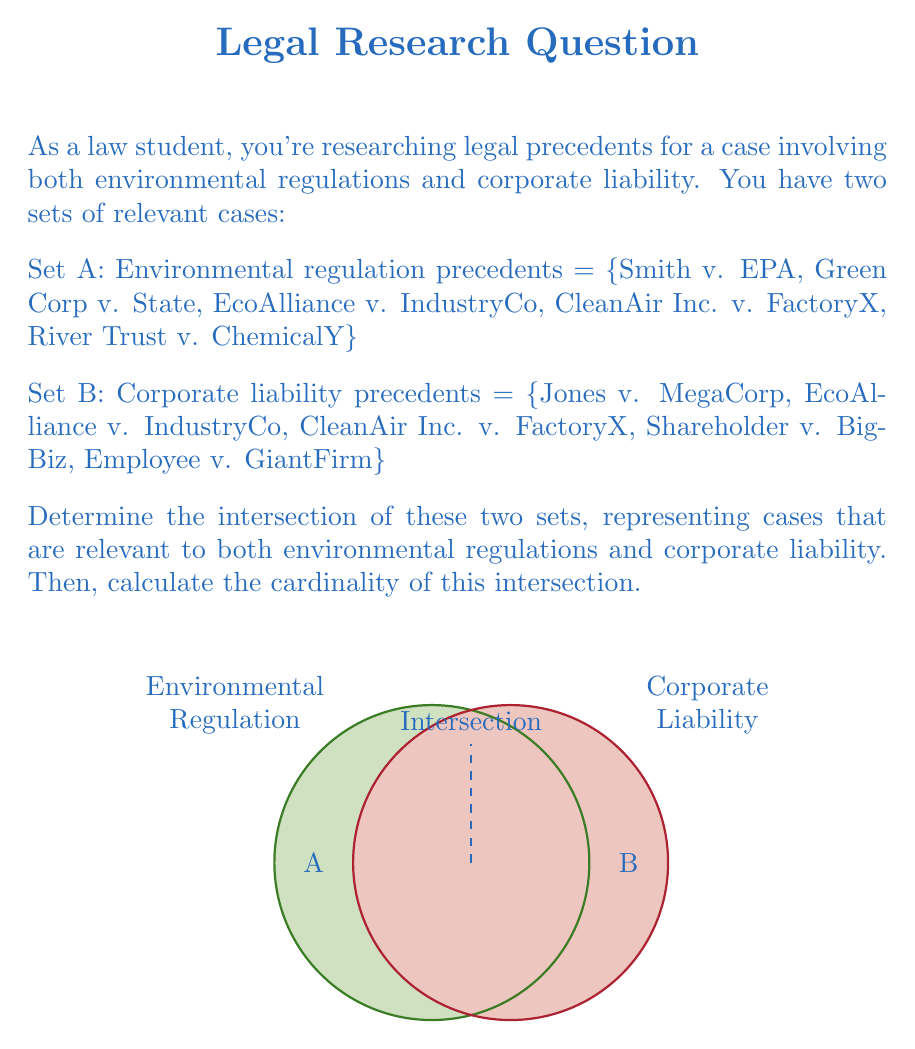Teach me how to tackle this problem. To solve this problem, we need to follow these steps:

1) Identify the elements that are present in both Set A and Set B. These elements form the intersection of the two sets.

2) We can represent the intersection mathematically as:
   $A \cap B = \{x : x \in A \text{ and } x \in B\}$

3) Examining the sets:
   Set A = {Smith v. EPA, Green Corp v. State, EcoAlliance v. IndustryCo, CleanAir Inc. v. FactoryX, River Trust v. ChemicalY}
   Set B = {Jones v. MegaCorp, EcoAlliance v. IndustryCo, CleanAir Inc. v. FactoryX, Shareholder v. BigBiz, Employee v. GiantFirm}

4) We can see that two cases appear in both sets:
   - EcoAlliance v. IndustryCo
   - CleanAir Inc. v. FactoryX

5) Therefore, the intersection is:
   $A \cap B = \text{\{EcoAlliance v. IndustryCo, CleanAir Inc. v. FactoryX\}}$

6) To calculate the cardinality of this intersection, we simply count the number of elements in the set.
   
7) The cardinality is denoted by vertical bars: $|A \cap B|$

8) In this case, $|A \cap B| = 2$

Thus, there are two cases that are relevant to both environmental regulations and corporate liability.
Answer: $A \cap B = \text{\{EcoAlliance v. IndustryCo, CleanAir Inc. v. FactoryX\}}$; $|A \cap B| = 2$ 